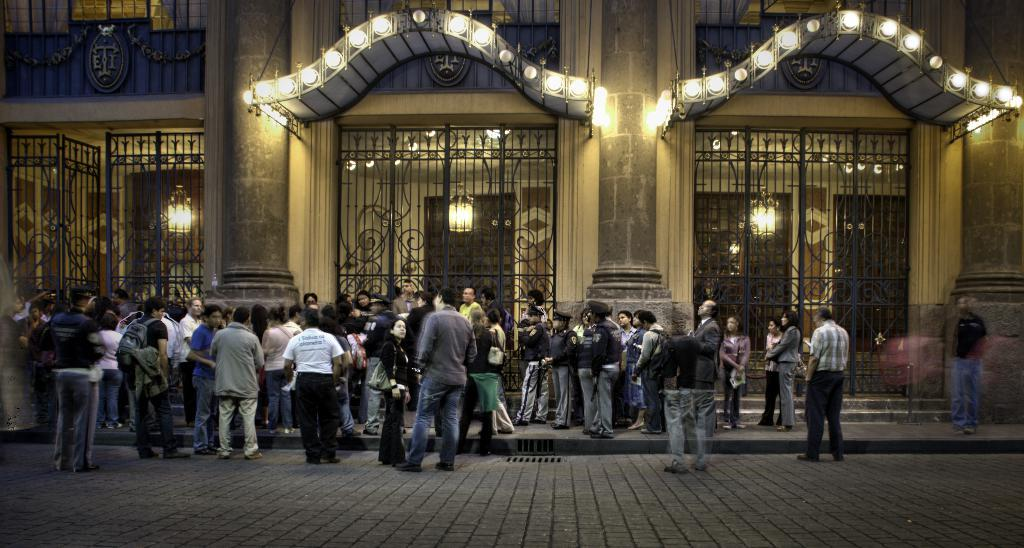What type of structure is visible in the image? There is a building in the image. What type of entrance can be seen in the image? There are gates in the image. What type of illumination is present in the image? There are lights in the image. Are there any people present in the image? Yes, there are people near the building. What is located at the bottom of the image? The bottom portion of the image contains a road. What type of quill is the mom using to write a receipt in the image? There is no mom, quill, or receipt present in the image. 